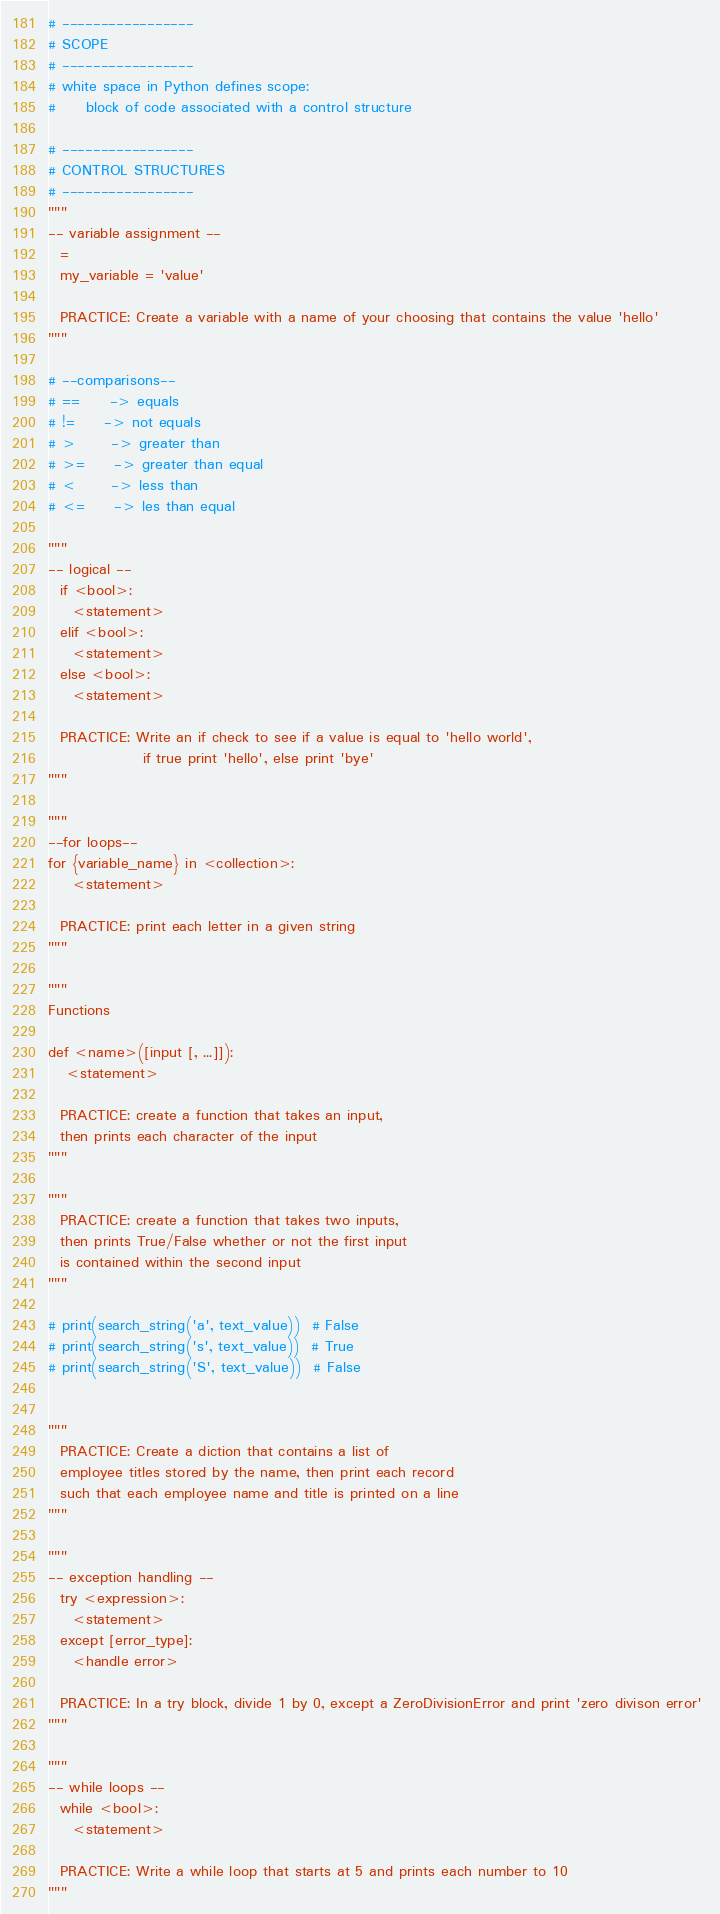Convert code to text. <code><loc_0><loc_0><loc_500><loc_500><_Python_>
# -----------------
# SCOPE
# -----------------
# white space in Python defines scope:
#     block of code associated with a control structure

# -----------------
# CONTROL STRUCTURES
# -----------------
"""
-- variable assignment --
  =
  my_variable = 'value'

  PRACTICE: Create a variable with a name of your choosing that contains the value 'hello'
"""

# --comparisons--
# ==     -> equals
# !=     -> not equals
# >      -> greater than
# >=     -> greater than equal
# <      -> less than
# <=     -> les than equal

"""
-- logical --
  if <bool>:
    <statement>
  elif <bool>:
    <statement>
  else <bool>:
    <statement>

  PRACTICE: Write an if check to see if a value is equal to 'hello world', 
                if true print 'hello', else print 'bye'
"""

"""
--for loops--
for {variable_name} in <collection>:
    <statement>

  PRACTICE: print each letter in a given string
"""

"""
Functions

def <name>([input [, ...]]):
   <statement>

  PRACTICE: create a function that takes an input,
  then prints each character of the input
"""

"""
  PRACTICE: create a function that takes two inputs,
  then prints True/False whether or not the first input
  is contained within the second input
"""

# print(search_string('a', text_value))  # False
# print(search_string('s', text_value))  # True
# print(search_string('S', text_value))  # False


"""
  PRACTICE: Create a diction that contains a list of 
  employee titles stored by the name, then print each record 
  such that each employee name and title is printed on a line
"""

"""
-- exception handling --
  try <expression>:
    <statement>
  except [error_type]:
    <handle error>

  PRACTICE: In a try block, divide 1 by 0, except a ZeroDivisionError and print 'zero divison error' 
"""

"""
-- while loops --
  while <bool>:
    <statement>

  PRACTICE: Write a while loop that starts at 5 and prints each number to 10
"""
</code> 